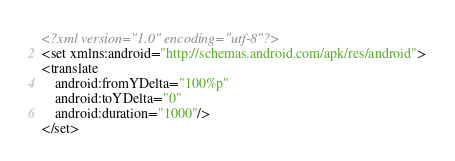<code> <loc_0><loc_0><loc_500><loc_500><_XML_><?xml version="1.0" encoding="utf-8"?>
<set xmlns:android="http://schemas.android.com/apk/res/android">
<translate
    android:fromYDelta="100%p"
    android:toYDelta="0"
    android:duration="1000"/>
</set></code> 